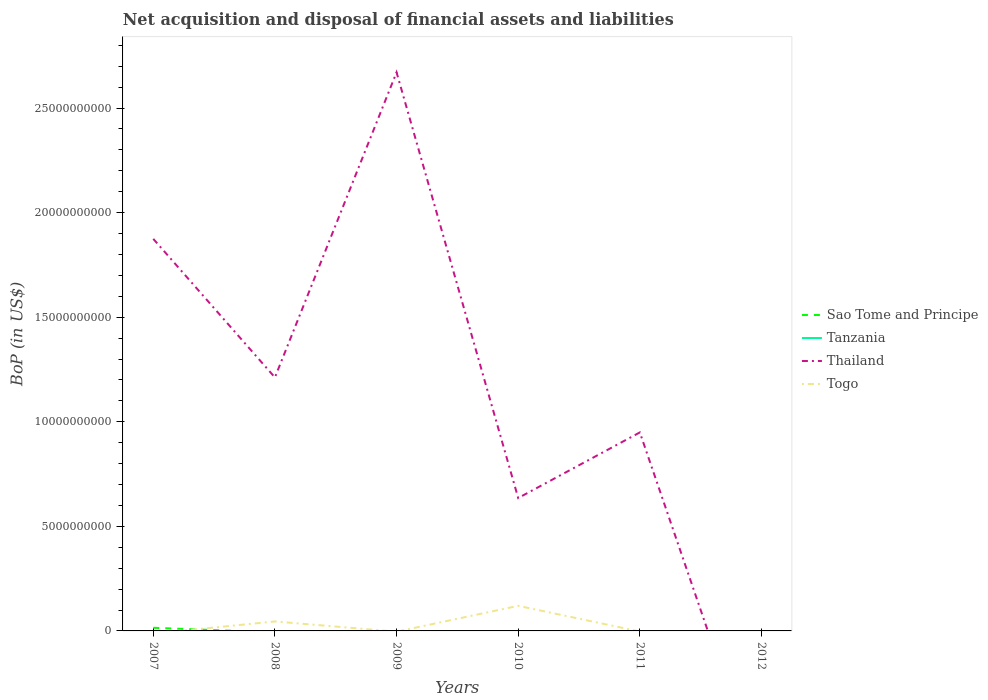How many different coloured lines are there?
Give a very brief answer. 3. Is the number of lines equal to the number of legend labels?
Your answer should be compact. No. Across all years, what is the maximum Balance of Payments in Togo?
Your answer should be compact. 0. What is the total Balance of Payments in Thailand in the graph?
Ensure brevity in your answer.  2.04e+1. What is the difference between the highest and the second highest Balance of Payments in Thailand?
Provide a succinct answer. 2.67e+1. Is the Balance of Payments in Tanzania strictly greater than the Balance of Payments in Thailand over the years?
Provide a short and direct response. No. How many years are there in the graph?
Your answer should be compact. 6. What is the difference between two consecutive major ticks on the Y-axis?
Your response must be concise. 5.00e+09. Are the values on the major ticks of Y-axis written in scientific E-notation?
Ensure brevity in your answer.  No. Does the graph contain grids?
Your answer should be very brief. No. How are the legend labels stacked?
Your response must be concise. Vertical. What is the title of the graph?
Your answer should be very brief. Net acquisition and disposal of financial assets and liabilities. What is the label or title of the Y-axis?
Your answer should be very brief. BoP (in US$). What is the BoP (in US$) in Sao Tome and Principe in 2007?
Ensure brevity in your answer.  1.50e+08. What is the BoP (in US$) of Thailand in 2007?
Your answer should be compact. 1.87e+1. What is the BoP (in US$) in Togo in 2007?
Ensure brevity in your answer.  0. What is the BoP (in US$) of Sao Tome and Principe in 2008?
Offer a terse response. 0. What is the BoP (in US$) of Tanzania in 2008?
Your response must be concise. 0. What is the BoP (in US$) in Thailand in 2008?
Your response must be concise. 1.21e+1. What is the BoP (in US$) in Togo in 2008?
Your answer should be very brief. 4.53e+08. What is the BoP (in US$) of Thailand in 2009?
Make the answer very short. 2.67e+1. What is the BoP (in US$) of Togo in 2009?
Ensure brevity in your answer.  0. What is the BoP (in US$) of Tanzania in 2010?
Offer a very short reply. 0. What is the BoP (in US$) of Thailand in 2010?
Offer a very short reply. 6.35e+09. What is the BoP (in US$) in Togo in 2010?
Ensure brevity in your answer.  1.20e+09. What is the BoP (in US$) in Sao Tome and Principe in 2011?
Provide a short and direct response. 0. What is the BoP (in US$) in Tanzania in 2011?
Provide a short and direct response. 0. What is the BoP (in US$) in Thailand in 2011?
Ensure brevity in your answer.  9.49e+09. What is the BoP (in US$) in Sao Tome and Principe in 2012?
Offer a very short reply. 0. What is the BoP (in US$) in Togo in 2012?
Provide a short and direct response. 0. Across all years, what is the maximum BoP (in US$) of Sao Tome and Principe?
Ensure brevity in your answer.  1.50e+08. Across all years, what is the maximum BoP (in US$) of Thailand?
Keep it short and to the point. 2.67e+1. Across all years, what is the maximum BoP (in US$) in Togo?
Keep it short and to the point. 1.20e+09. What is the total BoP (in US$) in Sao Tome and Principe in the graph?
Your response must be concise. 1.50e+08. What is the total BoP (in US$) in Thailand in the graph?
Give a very brief answer. 7.34e+1. What is the total BoP (in US$) in Togo in the graph?
Offer a very short reply. 1.65e+09. What is the difference between the BoP (in US$) in Thailand in 2007 and that in 2008?
Make the answer very short. 6.63e+09. What is the difference between the BoP (in US$) of Thailand in 2007 and that in 2009?
Keep it short and to the point. -7.96e+09. What is the difference between the BoP (in US$) in Thailand in 2007 and that in 2010?
Offer a very short reply. 1.24e+1. What is the difference between the BoP (in US$) of Thailand in 2007 and that in 2011?
Keep it short and to the point. 9.26e+09. What is the difference between the BoP (in US$) of Thailand in 2008 and that in 2009?
Keep it short and to the point. -1.46e+1. What is the difference between the BoP (in US$) in Thailand in 2008 and that in 2010?
Keep it short and to the point. 5.76e+09. What is the difference between the BoP (in US$) of Togo in 2008 and that in 2010?
Give a very brief answer. -7.46e+08. What is the difference between the BoP (in US$) in Thailand in 2008 and that in 2011?
Keep it short and to the point. 2.63e+09. What is the difference between the BoP (in US$) in Thailand in 2009 and that in 2010?
Your response must be concise. 2.04e+1. What is the difference between the BoP (in US$) in Thailand in 2009 and that in 2011?
Offer a terse response. 1.72e+1. What is the difference between the BoP (in US$) of Thailand in 2010 and that in 2011?
Your response must be concise. -3.14e+09. What is the difference between the BoP (in US$) in Sao Tome and Principe in 2007 and the BoP (in US$) in Thailand in 2008?
Give a very brief answer. -1.20e+1. What is the difference between the BoP (in US$) in Sao Tome and Principe in 2007 and the BoP (in US$) in Togo in 2008?
Provide a short and direct response. -3.03e+08. What is the difference between the BoP (in US$) in Thailand in 2007 and the BoP (in US$) in Togo in 2008?
Your response must be concise. 1.83e+1. What is the difference between the BoP (in US$) of Sao Tome and Principe in 2007 and the BoP (in US$) of Thailand in 2009?
Your response must be concise. -2.66e+1. What is the difference between the BoP (in US$) of Sao Tome and Principe in 2007 and the BoP (in US$) of Thailand in 2010?
Offer a very short reply. -6.20e+09. What is the difference between the BoP (in US$) of Sao Tome and Principe in 2007 and the BoP (in US$) of Togo in 2010?
Ensure brevity in your answer.  -1.05e+09. What is the difference between the BoP (in US$) in Thailand in 2007 and the BoP (in US$) in Togo in 2010?
Provide a succinct answer. 1.75e+1. What is the difference between the BoP (in US$) in Sao Tome and Principe in 2007 and the BoP (in US$) in Thailand in 2011?
Give a very brief answer. -9.34e+09. What is the difference between the BoP (in US$) in Thailand in 2008 and the BoP (in US$) in Togo in 2010?
Ensure brevity in your answer.  1.09e+1. What is the difference between the BoP (in US$) in Thailand in 2009 and the BoP (in US$) in Togo in 2010?
Provide a succinct answer. 2.55e+1. What is the average BoP (in US$) in Sao Tome and Principe per year?
Make the answer very short. 2.51e+07. What is the average BoP (in US$) of Thailand per year?
Provide a short and direct response. 1.22e+1. What is the average BoP (in US$) in Togo per year?
Provide a succinct answer. 2.75e+08. In the year 2007, what is the difference between the BoP (in US$) in Sao Tome and Principe and BoP (in US$) in Thailand?
Give a very brief answer. -1.86e+1. In the year 2008, what is the difference between the BoP (in US$) of Thailand and BoP (in US$) of Togo?
Your answer should be compact. 1.17e+1. In the year 2010, what is the difference between the BoP (in US$) of Thailand and BoP (in US$) of Togo?
Keep it short and to the point. 5.16e+09. What is the ratio of the BoP (in US$) of Thailand in 2007 to that in 2008?
Your response must be concise. 1.55. What is the ratio of the BoP (in US$) of Thailand in 2007 to that in 2009?
Provide a short and direct response. 0.7. What is the ratio of the BoP (in US$) in Thailand in 2007 to that in 2010?
Your answer should be very brief. 2.95. What is the ratio of the BoP (in US$) of Thailand in 2007 to that in 2011?
Give a very brief answer. 1.98. What is the ratio of the BoP (in US$) of Thailand in 2008 to that in 2009?
Your answer should be compact. 0.45. What is the ratio of the BoP (in US$) in Thailand in 2008 to that in 2010?
Offer a very short reply. 1.91. What is the ratio of the BoP (in US$) of Togo in 2008 to that in 2010?
Offer a very short reply. 0.38. What is the ratio of the BoP (in US$) in Thailand in 2008 to that in 2011?
Provide a succinct answer. 1.28. What is the ratio of the BoP (in US$) in Thailand in 2009 to that in 2010?
Your response must be concise. 4.2. What is the ratio of the BoP (in US$) in Thailand in 2009 to that in 2011?
Your response must be concise. 2.81. What is the ratio of the BoP (in US$) of Thailand in 2010 to that in 2011?
Offer a terse response. 0.67. What is the difference between the highest and the second highest BoP (in US$) of Thailand?
Provide a short and direct response. 7.96e+09. What is the difference between the highest and the lowest BoP (in US$) in Sao Tome and Principe?
Your answer should be very brief. 1.50e+08. What is the difference between the highest and the lowest BoP (in US$) of Thailand?
Offer a very short reply. 2.67e+1. What is the difference between the highest and the lowest BoP (in US$) in Togo?
Your answer should be very brief. 1.20e+09. 